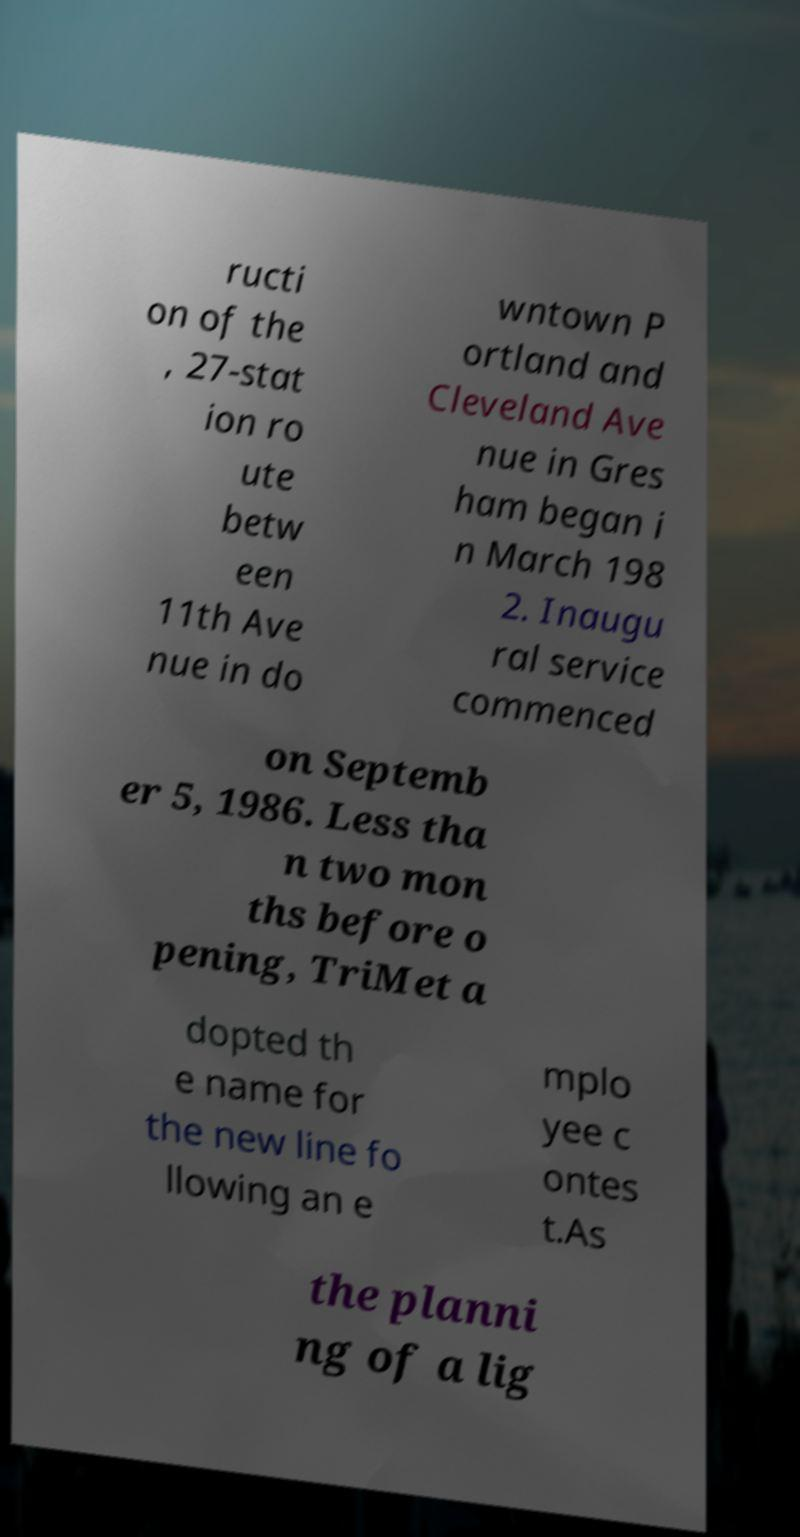Could you assist in decoding the text presented in this image and type it out clearly? ructi on of the , 27-stat ion ro ute betw een 11th Ave nue in do wntown P ortland and Cleveland Ave nue in Gres ham began i n March 198 2. Inaugu ral service commenced on Septemb er 5, 1986. Less tha n two mon ths before o pening, TriMet a dopted th e name for the new line fo llowing an e mplo yee c ontes t.As the planni ng of a lig 